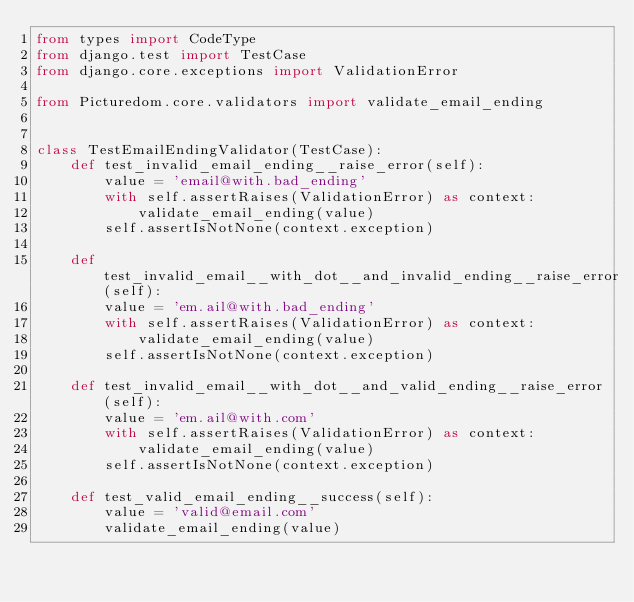<code> <loc_0><loc_0><loc_500><loc_500><_Python_>from types import CodeType
from django.test import TestCase
from django.core.exceptions import ValidationError

from Picturedom.core.validators import validate_email_ending


class TestEmailEndingValidator(TestCase):
    def test_invalid_email_ending__raise_error(self):
        value = 'email@with.bad_ending'
        with self.assertRaises(ValidationError) as context:
            validate_email_ending(value)
        self.assertIsNotNone(context.exception)

    def test_invalid_email__with_dot__and_invalid_ending__raise_error(self):
        value = 'em.ail@with.bad_ending'
        with self.assertRaises(ValidationError) as context:
            validate_email_ending(value)
        self.assertIsNotNone(context.exception)

    def test_invalid_email__with_dot__and_valid_ending__raise_error(self):
        value = 'em.ail@with.com'
        with self.assertRaises(ValidationError) as context:
            validate_email_ending(value)
        self.assertIsNotNone(context.exception)

    def test_valid_email_ending__success(self):
        value = 'valid@email.com'
        validate_email_ending(value)

</code> 